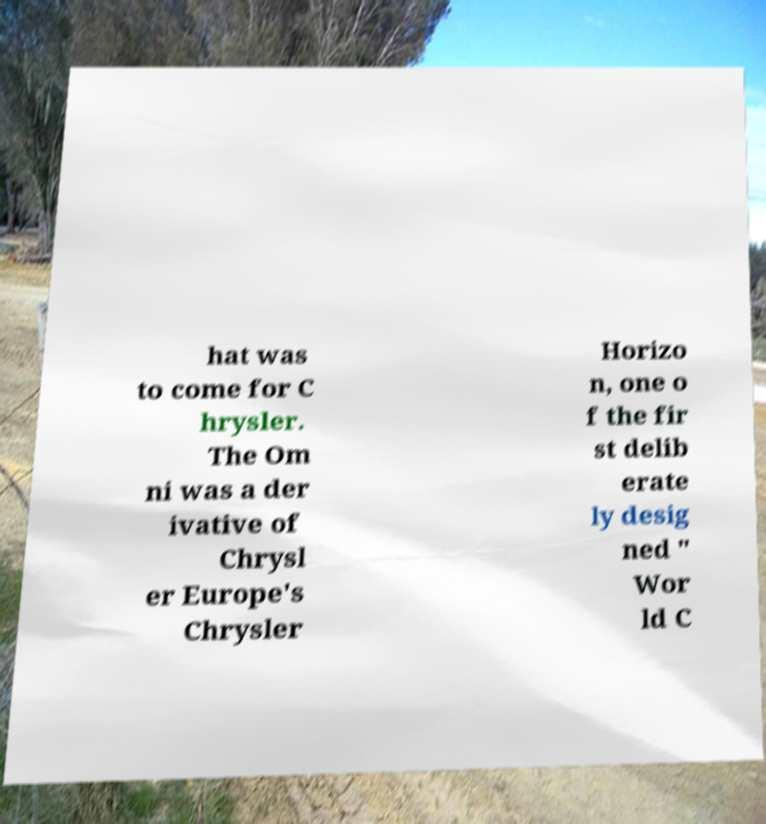Could you assist in decoding the text presented in this image and type it out clearly? hat was to come for C hrysler. The Om ni was a der ivative of Chrysl er Europe's Chrysler Horizo n, one o f the fir st delib erate ly desig ned " Wor ld C 